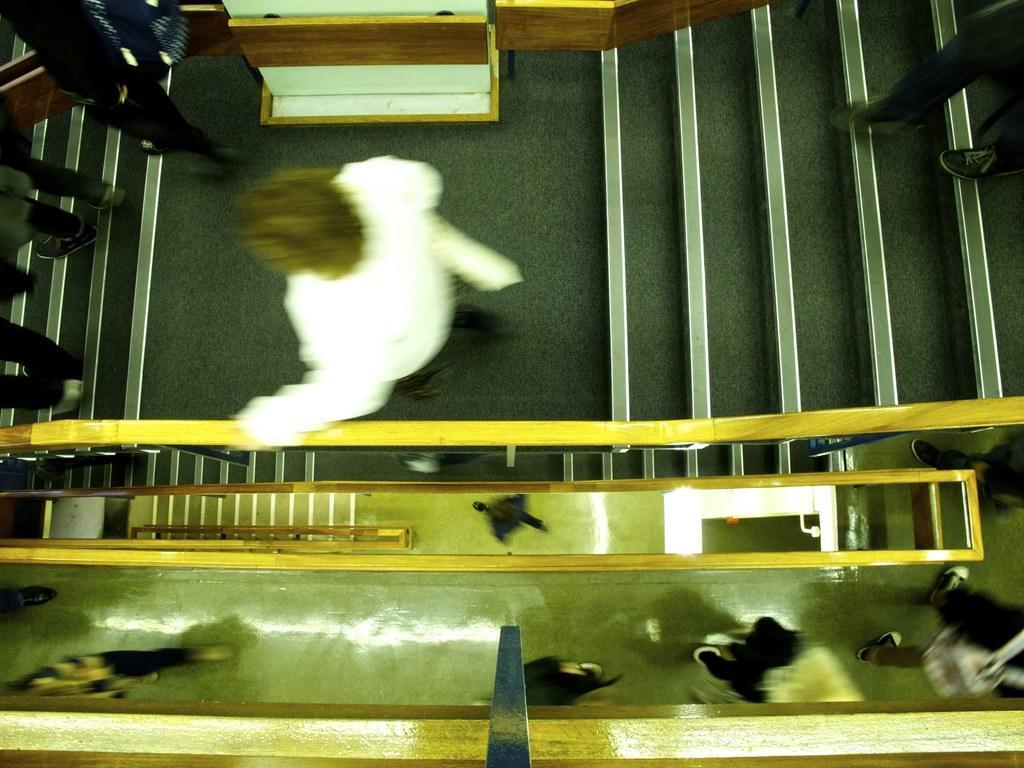Please provide a concise description of this image. In this picture I can see there are few people climb down the stairs and there are multiple floors and the image of a person. 